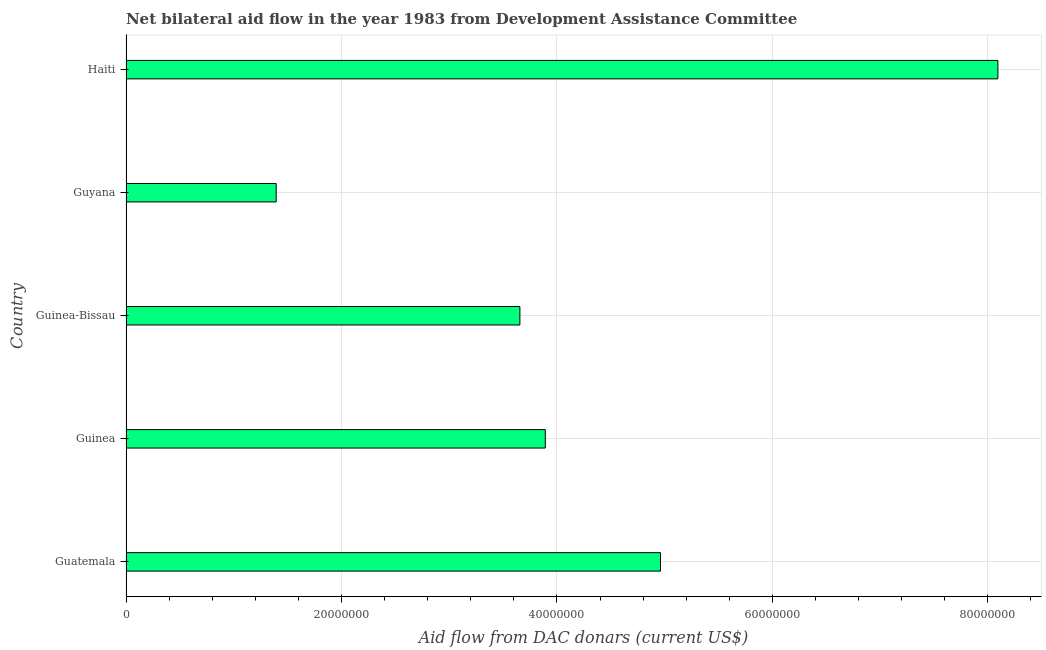Does the graph contain grids?
Ensure brevity in your answer.  Yes. What is the title of the graph?
Your response must be concise. Net bilateral aid flow in the year 1983 from Development Assistance Committee. What is the label or title of the X-axis?
Make the answer very short. Aid flow from DAC donars (current US$). What is the net bilateral aid flows from dac donors in Guatemala?
Offer a very short reply. 4.96e+07. Across all countries, what is the maximum net bilateral aid flows from dac donors?
Provide a short and direct response. 8.09e+07. Across all countries, what is the minimum net bilateral aid flows from dac donors?
Provide a succinct answer. 1.39e+07. In which country was the net bilateral aid flows from dac donors maximum?
Your response must be concise. Haiti. In which country was the net bilateral aid flows from dac donors minimum?
Keep it short and to the point. Guyana. What is the sum of the net bilateral aid flows from dac donors?
Offer a very short reply. 2.20e+08. What is the difference between the net bilateral aid flows from dac donors in Guinea and Guyana?
Offer a terse response. 2.50e+07. What is the average net bilateral aid flows from dac donors per country?
Your answer should be very brief. 4.40e+07. What is the median net bilateral aid flows from dac donors?
Offer a terse response. 3.89e+07. What is the ratio of the net bilateral aid flows from dac donors in Guinea to that in Guinea-Bissau?
Your answer should be very brief. 1.06. Is the net bilateral aid flows from dac donors in Guinea-Bissau less than that in Guyana?
Keep it short and to the point. No. What is the difference between the highest and the second highest net bilateral aid flows from dac donors?
Give a very brief answer. 3.13e+07. Is the sum of the net bilateral aid flows from dac donors in Guatemala and Guinea-Bissau greater than the maximum net bilateral aid flows from dac donors across all countries?
Offer a terse response. Yes. What is the difference between the highest and the lowest net bilateral aid flows from dac donors?
Offer a very short reply. 6.70e+07. How many bars are there?
Your response must be concise. 5. Are all the bars in the graph horizontal?
Give a very brief answer. Yes. Are the values on the major ticks of X-axis written in scientific E-notation?
Provide a short and direct response. No. What is the Aid flow from DAC donars (current US$) of Guatemala?
Provide a succinct answer. 4.96e+07. What is the Aid flow from DAC donars (current US$) of Guinea?
Give a very brief answer. 3.89e+07. What is the Aid flow from DAC donars (current US$) in Guinea-Bissau?
Give a very brief answer. 3.66e+07. What is the Aid flow from DAC donars (current US$) of Guyana?
Provide a short and direct response. 1.39e+07. What is the Aid flow from DAC donars (current US$) in Haiti?
Provide a short and direct response. 8.09e+07. What is the difference between the Aid flow from DAC donars (current US$) in Guatemala and Guinea?
Give a very brief answer. 1.07e+07. What is the difference between the Aid flow from DAC donars (current US$) in Guatemala and Guinea-Bissau?
Provide a short and direct response. 1.30e+07. What is the difference between the Aid flow from DAC donars (current US$) in Guatemala and Guyana?
Provide a short and direct response. 3.57e+07. What is the difference between the Aid flow from DAC donars (current US$) in Guatemala and Haiti?
Provide a succinct answer. -3.13e+07. What is the difference between the Aid flow from DAC donars (current US$) in Guinea and Guinea-Bissau?
Your response must be concise. 2.36e+06. What is the difference between the Aid flow from DAC donars (current US$) in Guinea and Guyana?
Your answer should be very brief. 2.50e+07. What is the difference between the Aid flow from DAC donars (current US$) in Guinea and Haiti?
Your answer should be very brief. -4.20e+07. What is the difference between the Aid flow from DAC donars (current US$) in Guinea-Bissau and Guyana?
Your response must be concise. 2.26e+07. What is the difference between the Aid flow from DAC donars (current US$) in Guinea-Bissau and Haiti?
Keep it short and to the point. -4.44e+07. What is the difference between the Aid flow from DAC donars (current US$) in Guyana and Haiti?
Offer a very short reply. -6.70e+07. What is the ratio of the Aid flow from DAC donars (current US$) in Guatemala to that in Guinea?
Provide a succinct answer. 1.27. What is the ratio of the Aid flow from DAC donars (current US$) in Guatemala to that in Guinea-Bissau?
Offer a very short reply. 1.36. What is the ratio of the Aid flow from DAC donars (current US$) in Guatemala to that in Guyana?
Your response must be concise. 3.56. What is the ratio of the Aid flow from DAC donars (current US$) in Guatemala to that in Haiti?
Your answer should be very brief. 0.61. What is the ratio of the Aid flow from DAC donars (current US$) in Guinea to that in Guinea-Bissau?
Keep it short and to the point. 1.06. What is the ratio of the Aid flow from DAC donars (current US$) in Guinea to that in Guyana?
Provide a short and direct response. 2.79. What is the ratio of the Aid flow from DAC donars (current US$) in Guinea to that in Haiti?
Give a very brief answer. 0.48. What is the ratio of the Aid flow from DAC donars (current US$) in Guinea-Bissau to that in Guyana?
Your response must be concise. 2.62. What is the ratio of the Aid flow from DAC donars (current US$) in Guinea-Bissau to that in Haiti?
Offer a very short reply. 0.45. What is the ratio of the Aid flow from DAC donars (current US$) in Guyana to that in Haiti?
Keep it short and to the point. 0.17. 